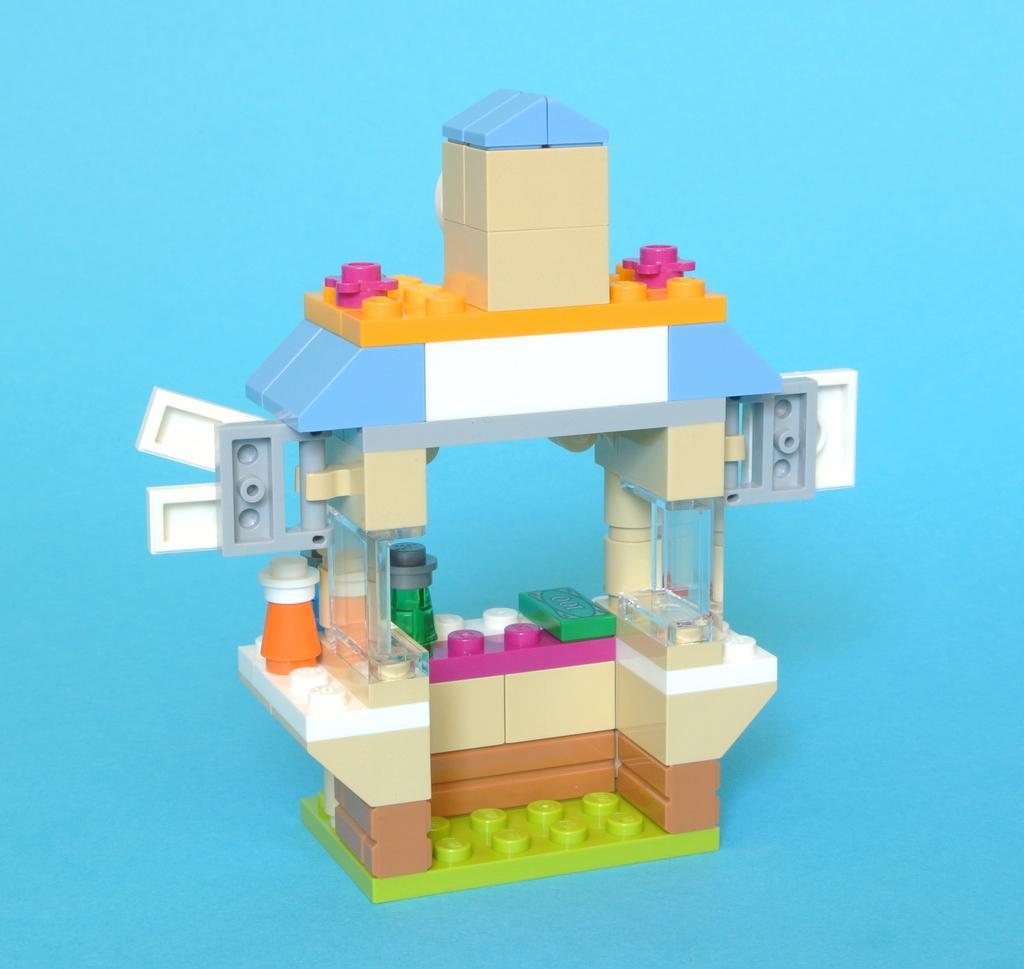Please provide a concise description of this image. In this picture we can see the puzzle block toy. Behind there is a blue color background. 